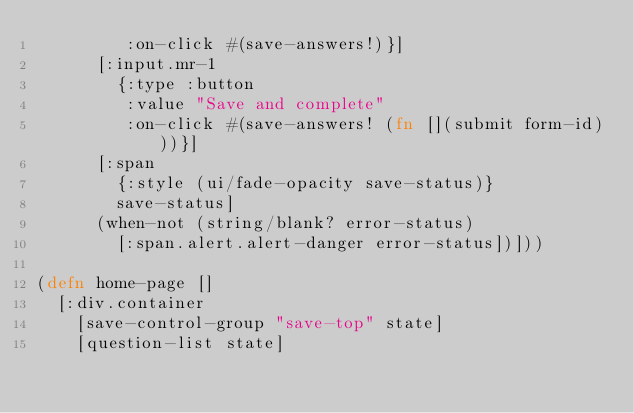Convert code to text. <code><loc_0><loc_0><loc_500><loc_500><_Clojure_>         :on-click #(save-answers!)}]
      [:input.mr-1
        {:type :button
         :value "Save and complete"
         :on-click #(save-answers! (fn [](submit form-id)))}]
      [:span
        {:style (ui/fade-opacity save-status)}
        save-status]
      (when-not (string/blank? error-status)
        [:span.alert.alert-danger error-status])]))

(defn home-page []
  [:div.container
    [save-control-group "save-top" state]
    [question-list state]</code> 